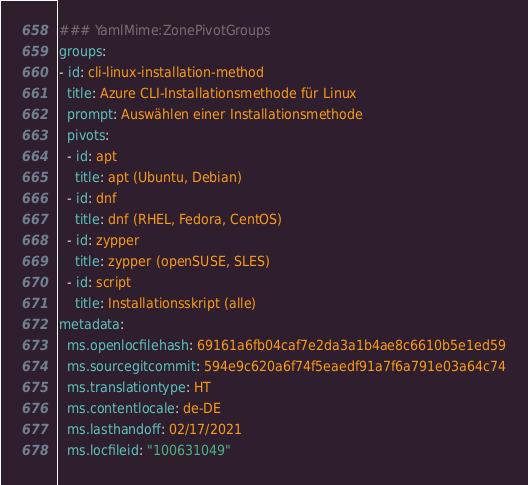Convert code to text. <code><loc_0><loc_0><loc_500><loc_500><_YAML_>### YamlMime:ZonePivotGroups
groups:
- id: cli-linux-installation-method
  title: Azure CLI-Installationsmethode für Linux
  prompt: Auswählen einer Installationsmethode
  pivots:
  - id: apt
    title: apt (Ubuntu, Debian)
  - id: dnf
    title: dnf (RHEL, Fedora, CentOS)
  - id: zypper
    title: zypper (openSUSE, SLES)
  - id: script
    title: Installationsskript (alle)
metadata:
  ms.openlocfilehash: 69161a6fb04caf7e2da3a1b4ae8c6610b5e1ed59
  ms.sourcegitcommit: 594e9c620a6f74f5eaedf91a7f6a791e03a64c74
  ms.translationtype: HT
  ms.contentlocale: de-DE
  ms.lasthandoff: 02/17/2021
  ms.locfileid: "100631049"
</code> 